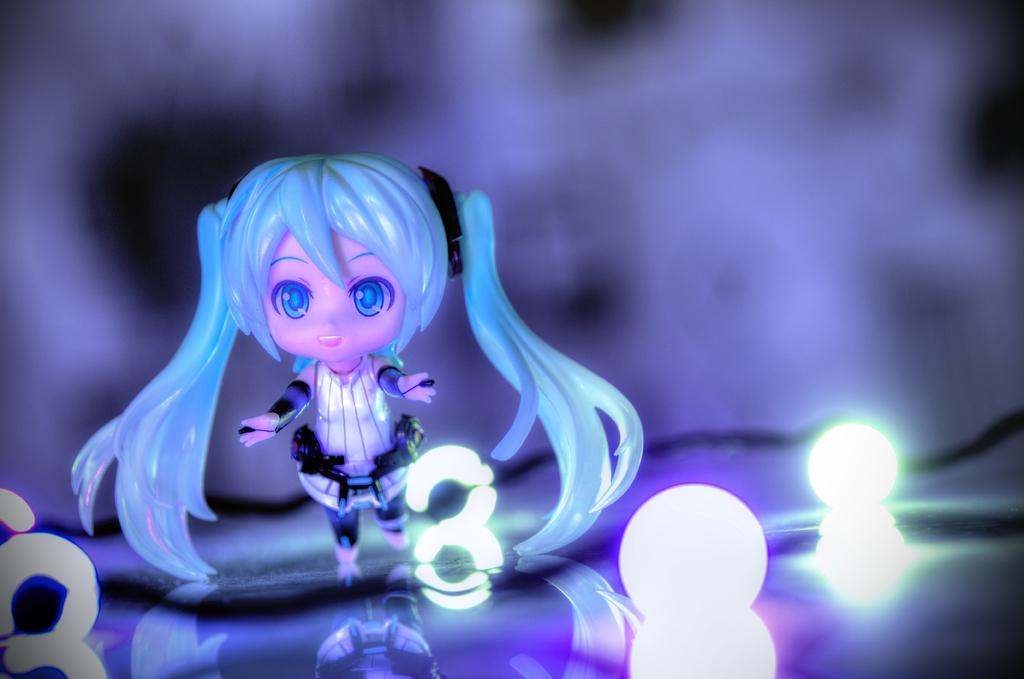What is the main subject in the image? There is a doll in the image. Where is the light located in the image? There is a light on the right side of the image. How would you describe the background of the image? The background of the image is blurred. What can be seen in the foreground of the image? There are lights and a cable in the foreground of the image. What type of destruction can be seen happening to the doll in the image? There is no destruction happening to the doll in the image; it appears to be intact. 